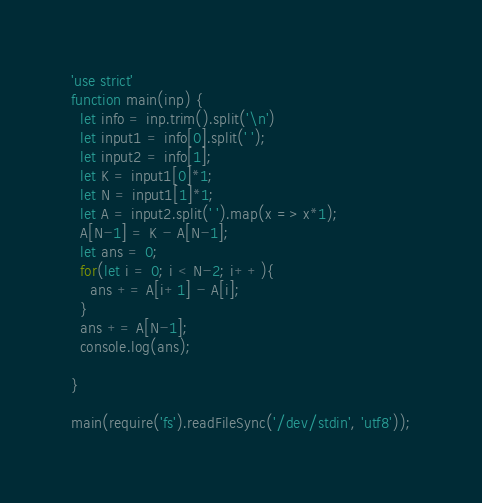Convert code to text. <code><loc_0><loc_0><loc_500><loc_500><_JavaScript_>'use strict'
function main(inp) {
  let info = inp.trim().split('\n')
  let input1 = info[0].split(' ');
  let input2 = info[1];
  let K = input1[0]*1;
  let N = input1[1]*1;
  let A = input2.split(' ').map(x => x*1);
  A[N-1] = K - A[N-1];
  let ans = 0;
  for(let i = 0; i < N-2; i++){
  	ans += A[i+1] - A[i];
  }
  ans += A[N-1];
  console.log(ans);
  
}

main(require('fs').readFileSync('/dev/stdin', 'utf8'));
</code> 